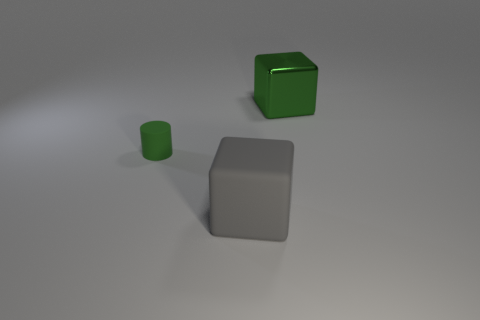If these objects were used in a still life painting, what mood might the artist be trying to convey? The simplicity and cleanliness of the objects, along with the neutral tones, could be used to convey a sense of calmness and minimalism in a still life painting. 